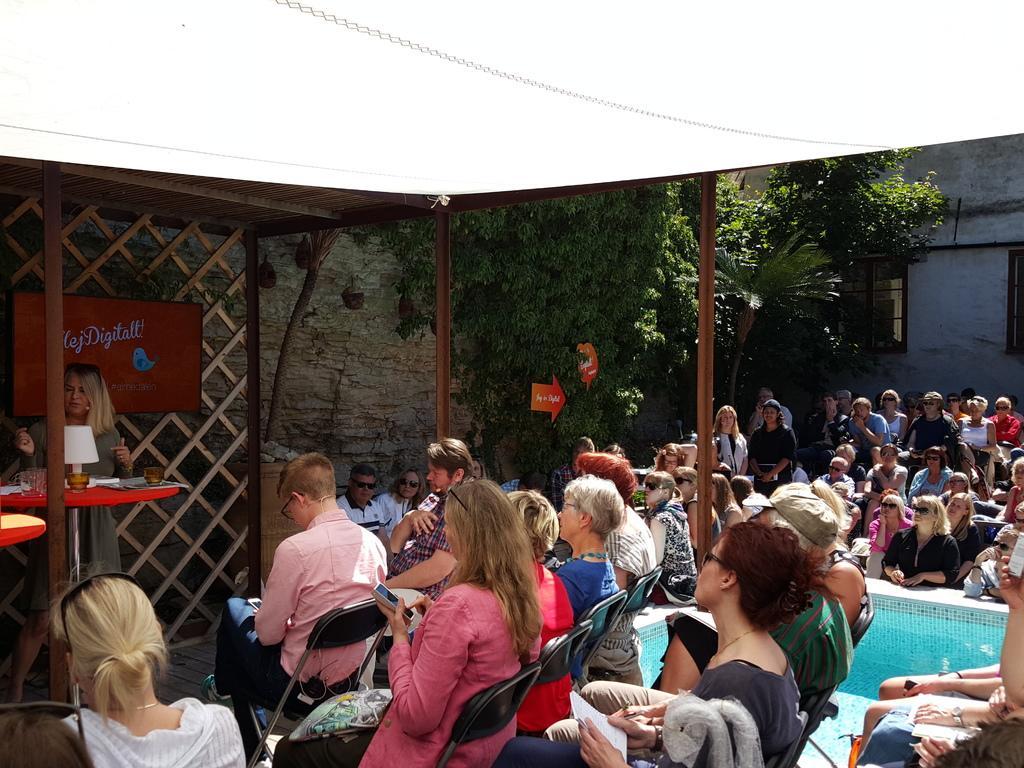How would you summarize this image in a sentence or two? In this picture I can see there are a group of people standing here and they are some other people sitting beside the pool and in the backdrop there are trees and a wall. 